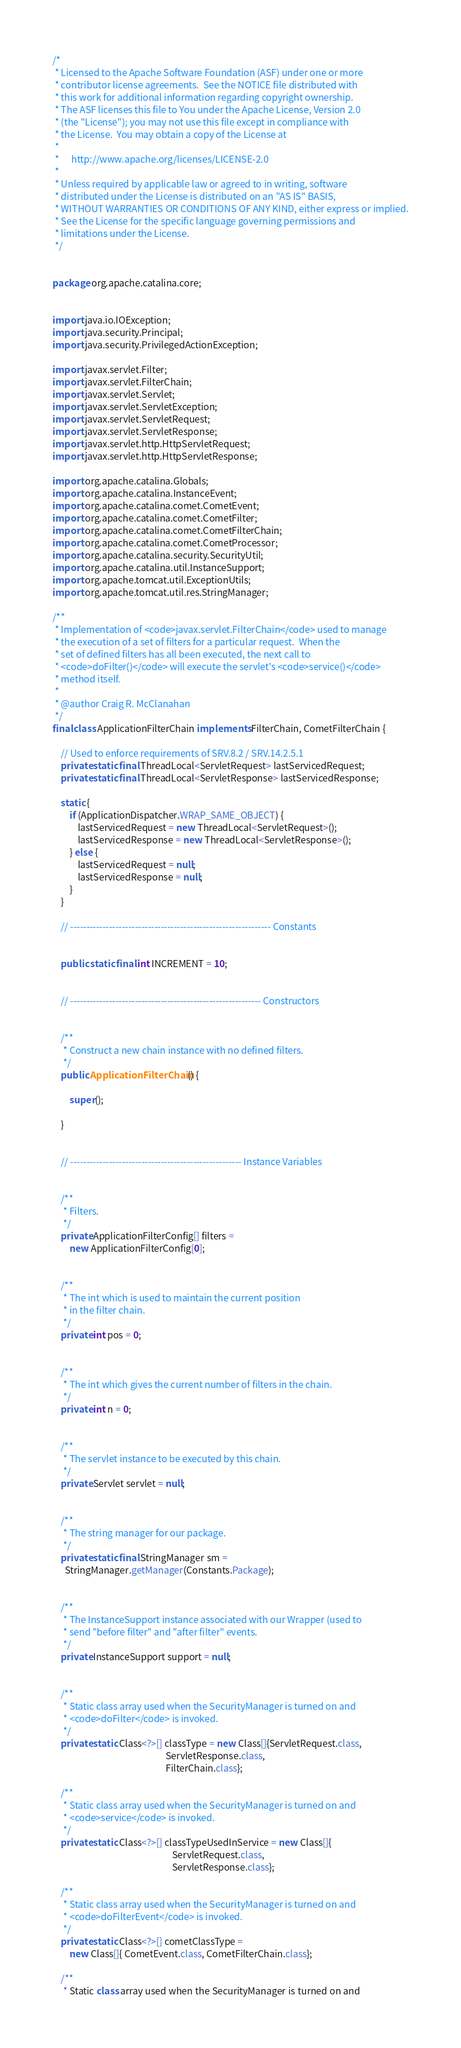<code> <loc_0><loc_0><loc_500><loc_500><_Java_>/*
 * Licensed to the Apache Software Foundation (ASF) under one or more
 * contributor license agreements.  See the NOTICE file distributed with
 * this work for additional information regarding copyright ownership.
 * The ASF licenses this file to You under the Apache License, Version 2.0
 * (the "License"); you may not use this file except in compliance with
 * the License.  You may obtain a copy of the License at
 *
 *      http://www.apache.org/licenses/LICENSE-2.0
 *
 * Unless required by applicable law or agreed to in writing, software
 * distributed under the License is distributed on an "AS IS" BASIS,
 * WITHOUT WARRANTIES OR CONDITIONS OF ANY KIND, either express or implied.
 * See the License for the specific language governing permissions and
 * limitations under the License.
 */


package org.apache.catalina.core;


import java.io.IOException;
import java.security.Principal;
import java.security.PrivilegedActionException;

import javax.servlet.Filter;
import javax.servlet.FilterChain;
import javax.servlet.Servlet;
import javax.servlet.ServletException;
import javax.servlet.ServletRequest;
import javax.servlet.ServletResponse;
import javax.servlet.http.HttpServletRequest;
import javax.servlet.http.HttpServletResponse;

import org.apache.catalina.Globals;
import org.apache.catalina.InstanceEvent;
import org.apache.catalina.comet.CometEvent;
import org.apache.catalina.comet.CometFilter;
import org.apache.catalina.comet.CometFilterChain;
import org.apache.catalina.comet.CometProcessor;
import org.apache.catalina.security.SecurityUtil;
import org.apache.catalina.util.InstanceSupport;
import org.apache.tomcat.util.ExceptionUtils;
import org.apache.tomcat.util.res.StringManager;

/**
 * Implementation of <code>javax.servlet.FilterChain</code> used to manage
 * the execution of a set of filters for a particular request.  When the
 * set of defined filters has all been executed, the next call to
 * <code>doFilter()</code> will execute the servlet's <code>service()</code>
 * method itself.
 *
 * @author Craig R. McClanahan
 */
final class ApplicationFilterChain implements FilterChain, CometFilterChain {

    // Used to enforce requirements of SRV.8.2 / SRV.14.2.5.1
    private static final ThreadLocal<ServletRequest> lastServicedRequest;
    private static final ThreadLocal<ServletResponse> lastServicedResponse;

    static {
        if (ApplicationDispatcher.WRAP_SAME_OBJECT) {
            lastServicedRequest = new ThreadLocal<ServletRequest>();
            lastServicedResponse = new ThreadLocal<ServletResponse>();
        } else {
            lastServicedRequest = null;
            lastServicedResponse = null;
        }
    }

    // -------------------------------------------------------------- Constants


    public static final int INCREMENT = 10;


    // ----------------------------------------------------------- Constructors


    /**
     * Construct a new chain instance with no defined filters.
     */
    public ApplicationFilterChain() {

        super();

    }


    // ----------------------------------------------------- Instance Variables


    /**
     * Filters.
     */
    private ApplicationFilterConfig[] filters =
        new ApplicationFilterConfig[0];


    /**
     * The int which is used to maintain the current position
     * in the filter chain.
     */
    private int pos = 0;


    /**
     * The int which gives the current number of filters in the chain.
     */
    private int n = 0;


    /**
     * The servlet instance to be executed by this chain.
     */
    private Servlet servlet = null;


    /**
     * The string manager for our package.
     */
    private static final StringManager sm =
      StringManager.getManager(Constants.Package);


    /**
     * The InstanceSupport instance associated with our Wrapper (used to
     * send "before filter" and "after filter" events.
     */
    private InstanceSupport support = null;


    /**
     * Static class array used when the SecurityManager is turned on and
     * <code>doFilter</code> is invoked.
     */
    private static Class<?>[] classType = new Class[]{ServletRequest.class,
                                                      ServletResponse.class,
                                                      FilterChain.class};

    /**
     * Static class array used when the SecurityManager is turned on and
     * <code>service</code> is invoked.
     */
    private static Class<?>[] classTypeUsedInService = new Class[]{
                                                         ServletRequest.class,
                                                         ServletResponse.class};

    /**
     * Static class array used when the SecurityManager is turned on and
     * <code>doFilterEvent</code> is invoked.
     */
    private static Class<?>[] cometClassType =
        new Class[]{ CometEvent.class, CometFilterChain.class};

    /**
     * Static class array used when the SecurityManager is turned on and</code> 